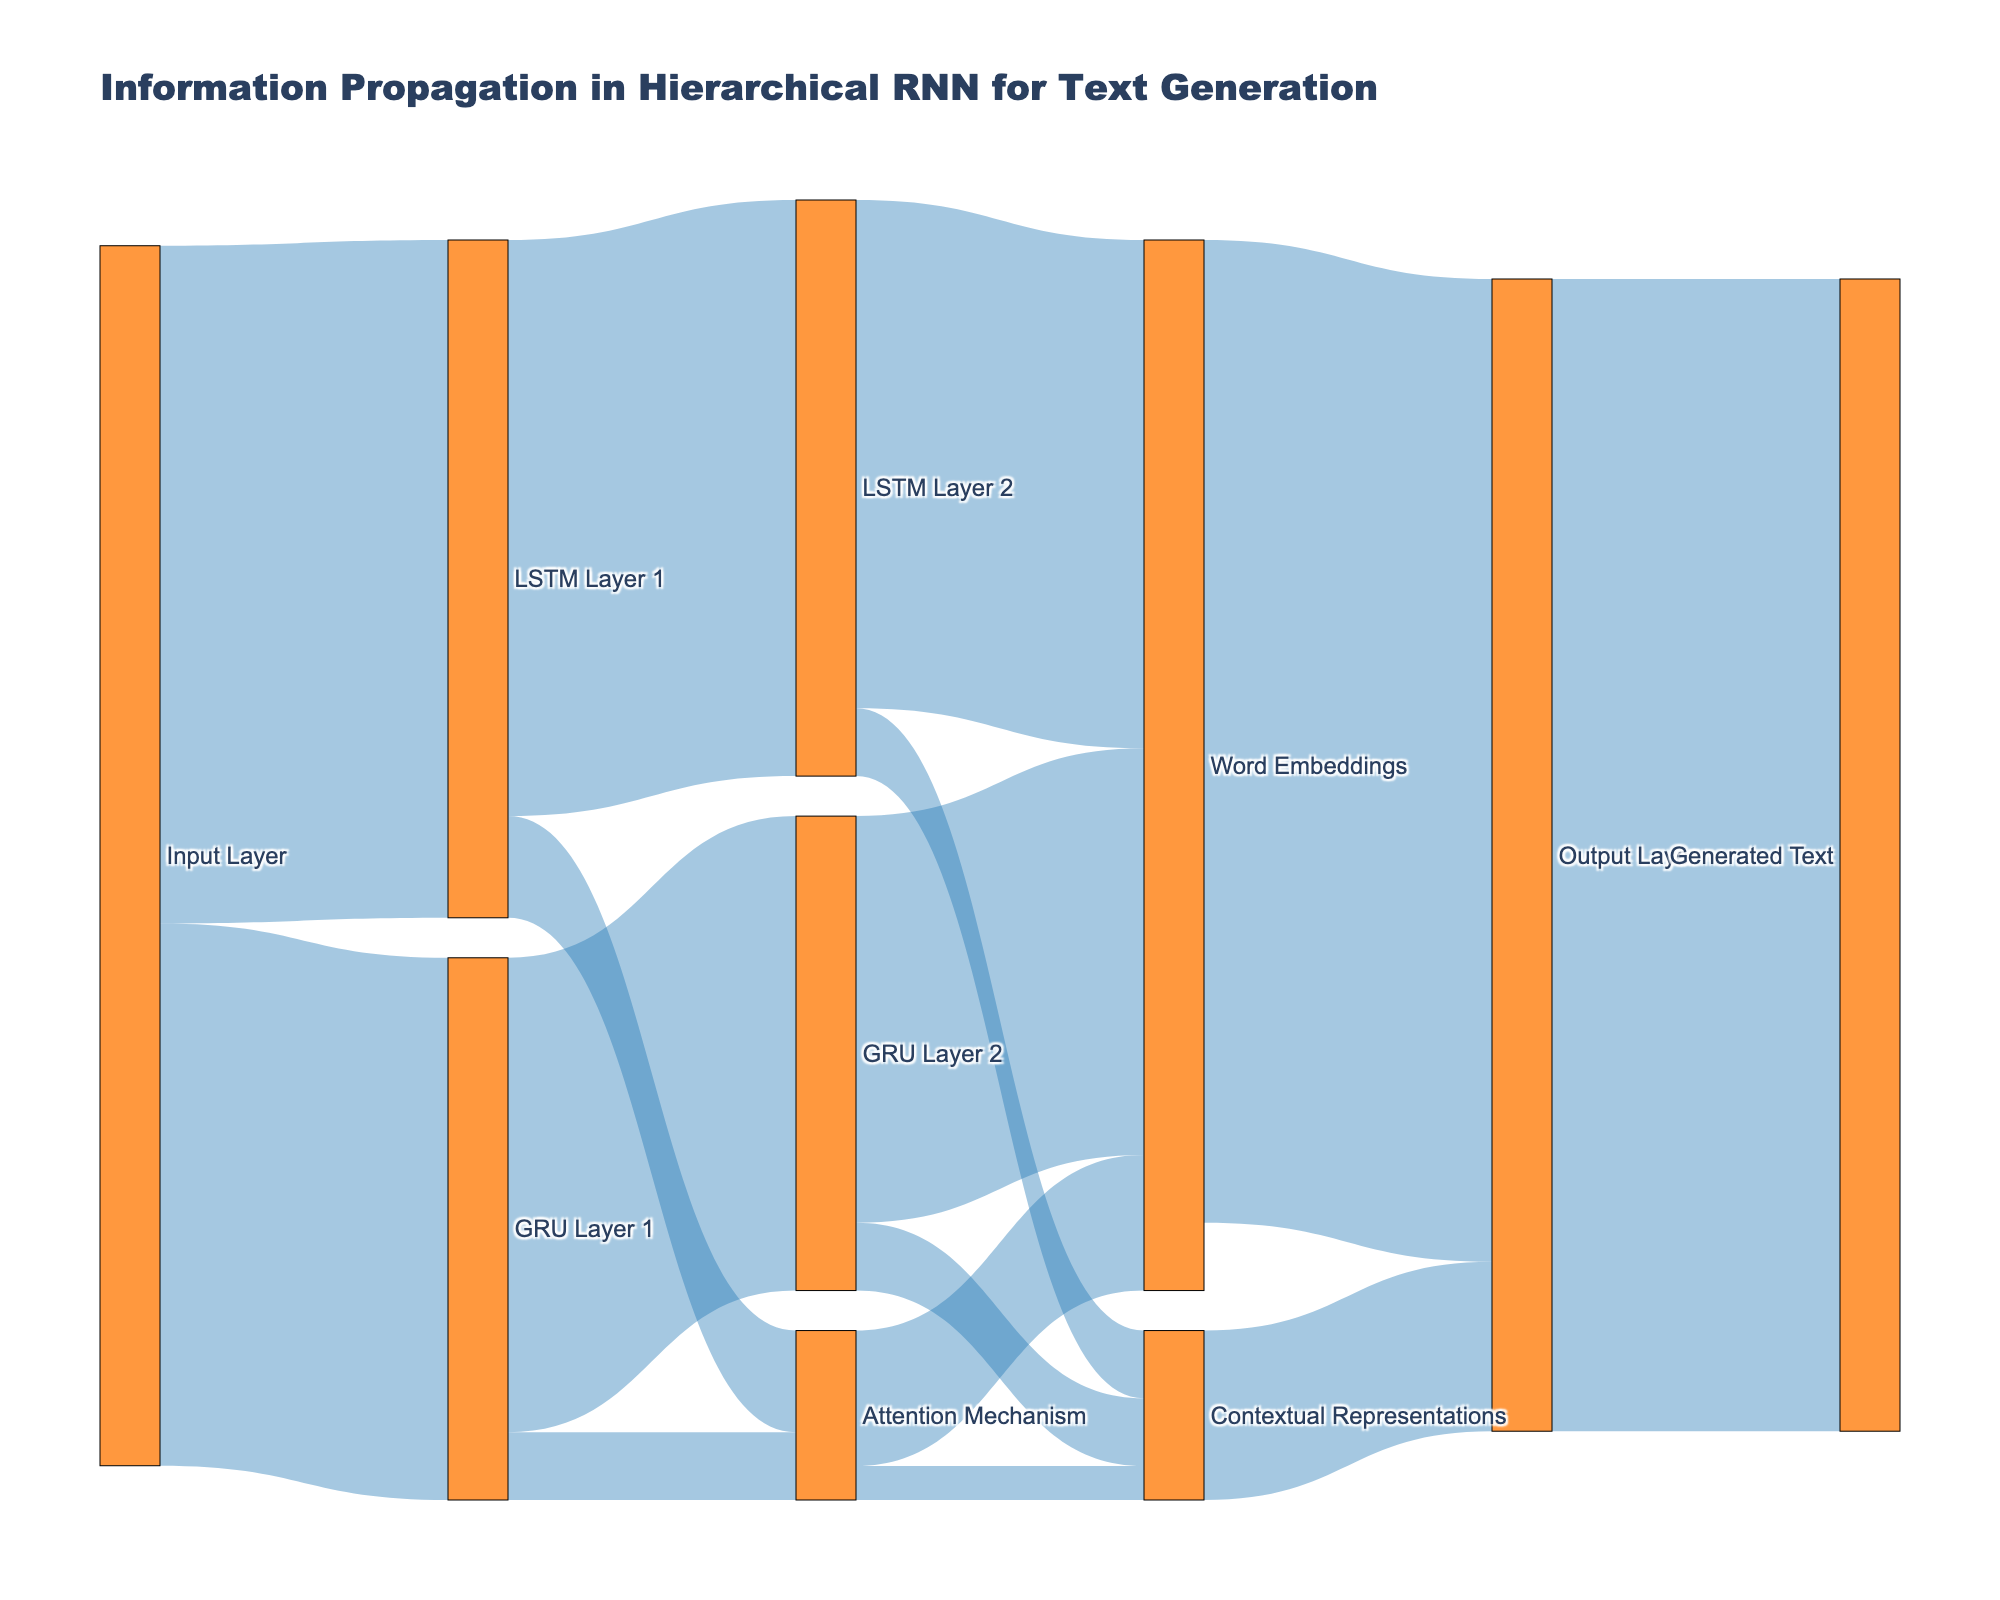What's the total value flowing from the Input Layer? The total value flowing from the Input Layer can be found by summing the values of the links originating from it. From the figure, these are: LSTM Layer 1 (100) and GRU Layer 1 (80). Adding these together gives 100 + 80 = 180.
Answer: 180 Which layer receives the highest value from the Attention Mechanism? To identify which layer receives the highest value from the Attention Mechanism, compare the values going to different layers. From the figure, the values are: Word Embeddings (20) and Contextual Representations (5). Word Embeddings receives 20, which is larger than 5.
Answer: Word Embeddings How much value flows into the LSTM Layer 2? The value flowing into LSTM Layer 2 is the sum of the values from the links that connect to it. From the figure, this value comes from LSTM Layer 1 and is 85.
Answer: 85 What is the total value that reaches the Word Embeddings? To find the total value reaching Word Embeddings, sum the values of the links leading to it. From the figure, these values are: LSTM Layer 2 (75), GRU Layer 2 (60), and Attention Mechanism (20). Thus, the total is 75 + 60 + 20 = 155.
Answer: 155 Compare the values flowing from LSTM Layer 1 and GRU Layer 1 to the Attention Mechanism. Which is greater? From the figure, LSTM Layer 1 sends 15 to the Attention Mechanism, while GRU Layer 1 sends 10. Comparing these, the flow from LSTM Layer 1 is greater.
Answer: LSTM Layer 1 What's the combined value flowing from the LSTM Layer 2 and GRU Layer 2 to Contextual Representations? The combined value is found by adding the values from LSTM Layer 2 (10) and GRU Layer 2 (10) to Contextual Representations. The sum is 10 + 10 = 20.
Answer: 20 What is the final total value at the Output Layer? From the figure, the total value at the Output Layer is the sum of the Word Embeddings (145) and Contextual Representations (25) linking to it. Therefore, 145 + 25 = 170.
Answer: 170 